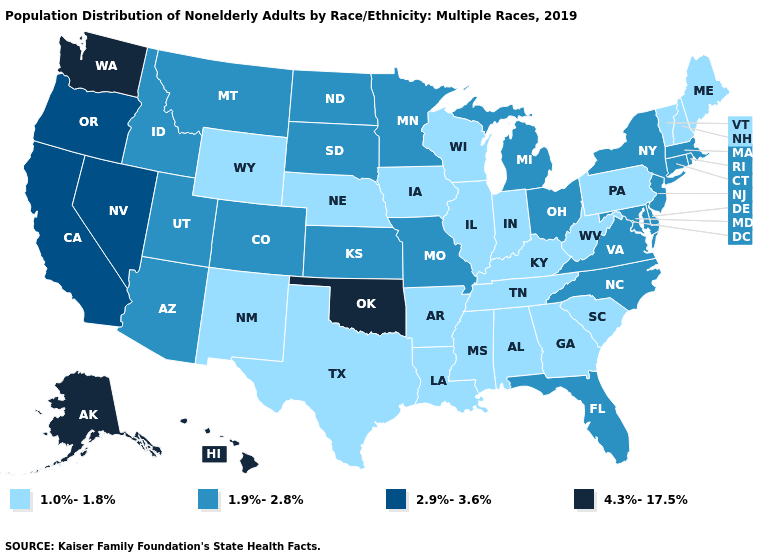What is the highest value in the MidWest ?
Write a very short answer. 1.9%-2.8%. Name the states that have a value in the range 2.9%-3.6%?
Give a very brief answer. California, Nevada, Oregon. Which states hav the highest value in the MidWest?
Answer briefly. Kansas, Michigan, Minnesota, Missouri, North Dakota, Ohio, South Dakota. Does West Virginia have the lowest value in the South?
Keep it brief. Yes. Name the states that have a value in the range 1.0%-1.8%?
Write a very short answer. Alabama, Arkansas, Georgia, Illinois, Indiana, Iowa, Kentucky, Louisiana, Maine, Mississippi, Nebraska, New Hampshire, New Mexico, Pennsylvania, South Carolina, Tennessee, Texas, Vermont, West Virginia, Wisconsin, Wyoming. Is the legend a continuous bar?
Keep it brief. No. What is the value of Maine?
Quick response, please. 1.0%-1.8%. Does the first symbol in the legend represent the smallest category?
Keep it brief. Yes. Does the map have missing data?
Answer briefly. No. What is the value of New York?
Quick response, please. 1.9%-2.8%. Which states hav the highest value in the Northeast?
Keep it brief. Connecticut, Massachusetts, New Jersey, New York, Rhode Island. What is the value of New Mexico?
Answer briefly. 1.0%-1.8%. Name the states that have a value in the range 1.9%-2.8%?
Quick response, please. Arizona, Colorado, Connecticut, Delaware, Florida, Idaho, Kansas, Maryland, Massachusetts, Michigan, Minnesota, Missouri, Montana, New Jersey, New York, North Carolina, North Dakota, Ohio, Rhode Island, South Dakota, Utah, Virginia. What is the value of Colorado?
Write a very short answer. 1.9%-2.8%. Does Ohio have the lowest value in the USA?
Keep it brief. No. 